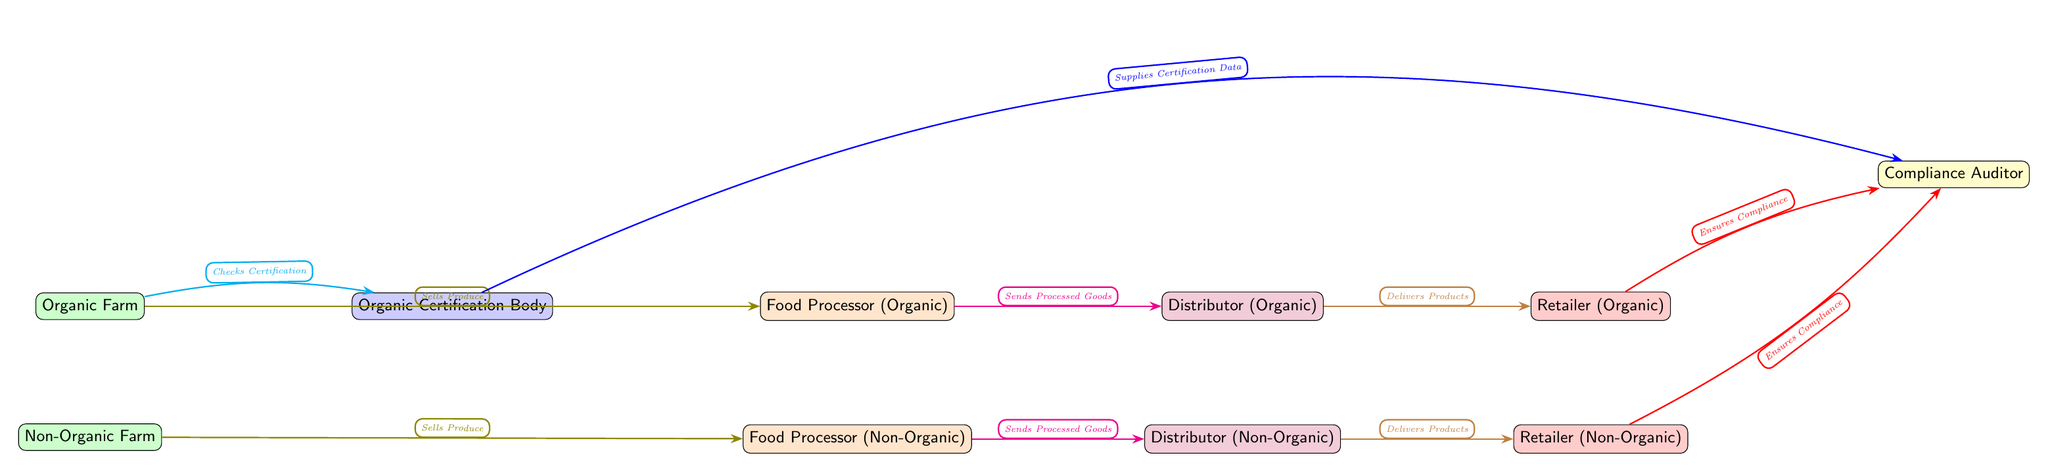What is the first node in the diagram? The first node in the diagram is labeled "Organic Farm," which is positioned at the top of the diagram.
Answer: Organic Farm How many processors are identified in the diagram? The diagram lists two processors: "Food Processor (Organic)" and "Food Processor (Non-Organic)," indicating there are two processors total.
Answer: 2 What type of body checks the certification of organic farms? The diagram identifies "Organic Certification Body" as the entity responsible for checking the certification of organic farms.
Answer: Organic Certification Body Which node ensures compliance for organic retailers? The "Compliance Auditor" node ensures compliance for organic retailers, as indicated by the directed arrow from "Retailer (Organic)" to "Compliance Auditor."
Answer: Compliance Auditor What do non-organic farms sell? Non-organic farms sell produce, which is represented by the arrow from "Non-Organic Farm" to "Food Processor (Non-Organic)."
Answer: Produce Which direction does the distributor for organic products deliver products? The organic distributor delivers products to the "Retailer (Organic)," as indicated by the directed arrow pointing from the distributor to the retailer.
Answer: To Retailer (Organic) What type of relationship exists between the "Organic Certification Body" and the "Compliance Auditor"? The relationship is a data supply relationship, where the "Organic Certification Body" supplies certification data to the "Compliance Auditor," as shown by the directed arrow connecting them.
Answer: Supplies Certification Data How does the organic farm interact with the compliance auditor? The interaction occurs indirectly; the organic farm checks certification from the "Organic Certification Body," which then supplies certification data to the "Compliance Auditor."
Answer: Indirectly through certification body How many retailers are listed in the diagram? The diagram includes two retailers: "Retailer (Organic)" and "Retailer (Non-Organic)," totaling two retailers that are visible in the diagram.
Answer: 2 What is the relationship type between the food processors and their respective distributors? The relationship type is one of sending processed goods, as seen by the arrows from both processors to their respective distributors indicating the flow of goods.
Answer: Sends Processed Goods 